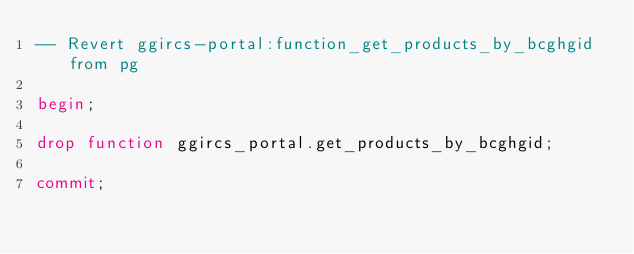<code> <loc_0><loc_0><loc_500><loc_500><_SQL_>-- Revert ggircs-portal:function_get_products_by_bcghgid from pg

begin;

drop function ggircs_portal.get_products_by_bcghgid;

commit;
</code> 